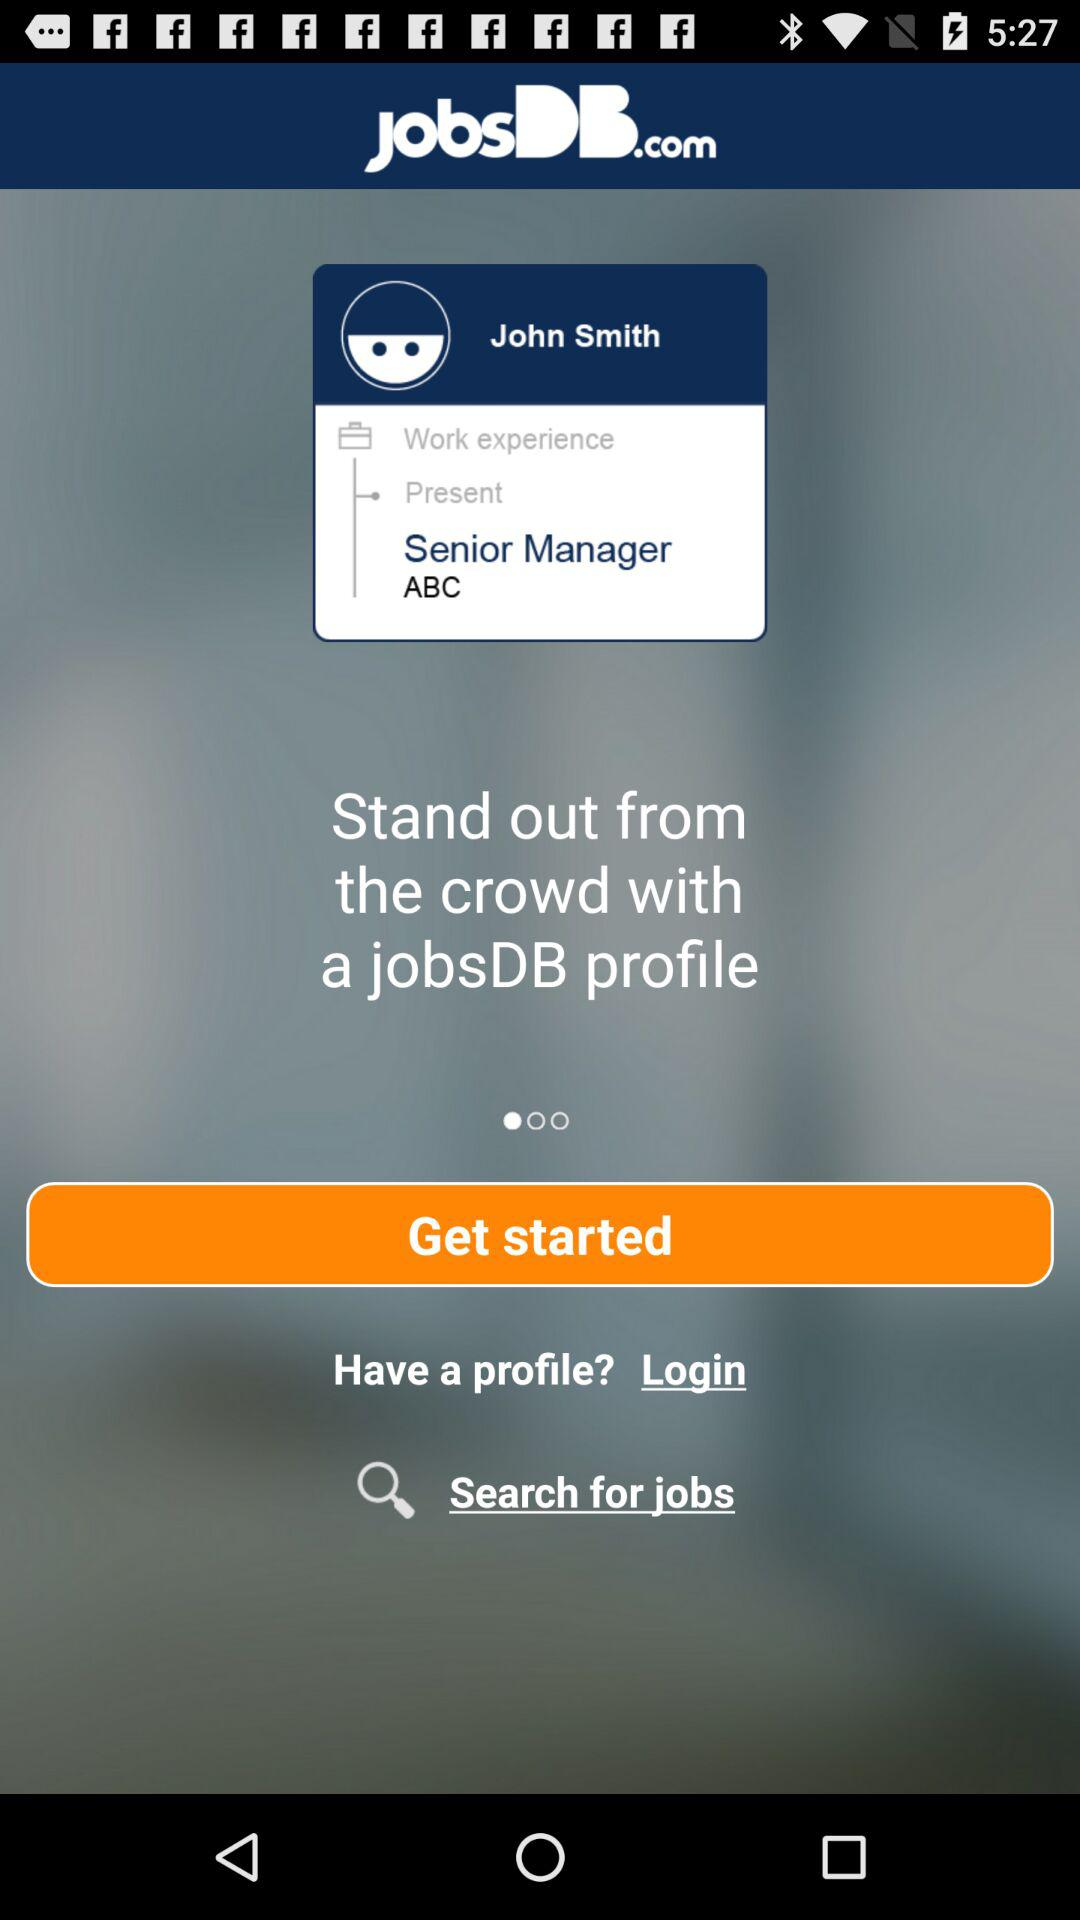What is the name of the user? The name of the user is John Smith. 